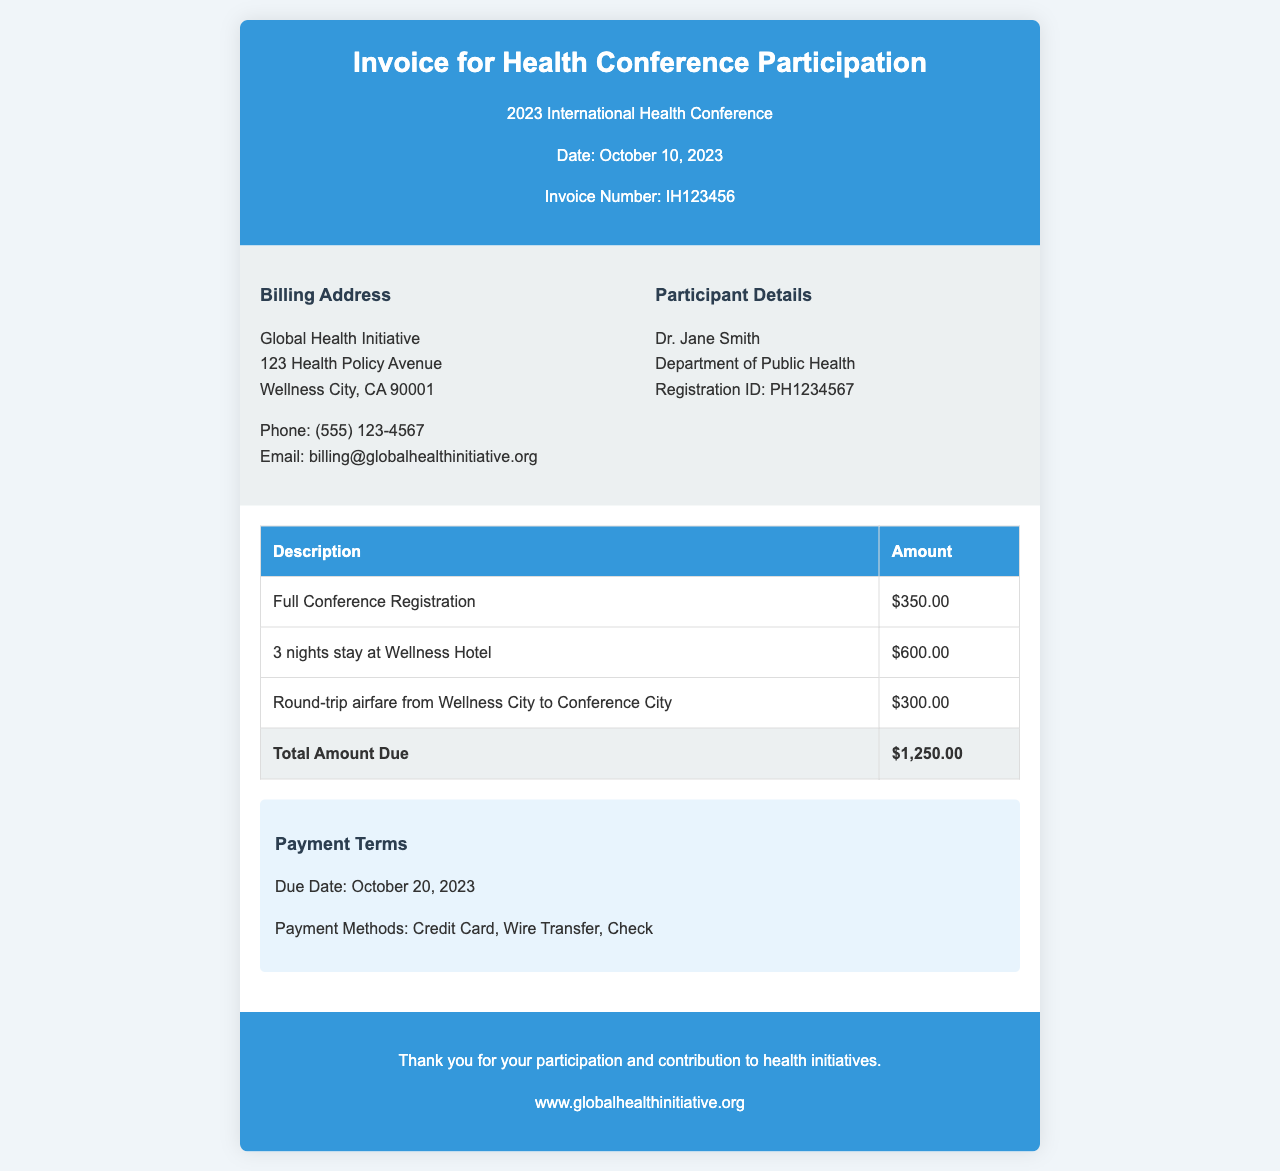What is the total amount due? The total amount due is stated at the bottom of the invoice summary table, which sums up registration, accommodation, and travel expenses.
Answer: $1,250.00 When is the payment due date? The due date for payment is clearly mentioned in the payment terms section of the invoice.
Answer: October 20, 2023 How many nights did Dr. Jane Smith stay at the hotel? The invoice specifies the duration of stay in the accommodation description.
Answer: 3 nights What is the registration ID for the participant? The registration ID is provided in the participant details section of the invoice.
Answer: PH1234567 What methods of payment are accepted? The payment methods are listed in the payment terms section of the invoice.
Answer: Credit Card, Wire Transfer, Check Who is the billing address for the invoice? The billing address section provides the name and address to which the invoice is addressed.
Answer: Global Health Initiative, 123 Health Policy Avenue, Wellness City, CA 90001 What was the airfare cost? The airfare cost is outlined under the travel expenses in the invoice body.
Answer: $300.00 Which hotel did Dr. Jane Smith stay at? The hotel can be identified through the accommodation description in the invoice.
Answer: Wellness Hotel What was the cost for full conference registration? The cost for full conference registration is listed in the invoice summary table.
Answer: $350.00 